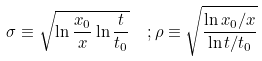<formula> <loc_0><loc_0><loc_500><loc_500>\sigma \equiv \sqrt { \ln \frac { x _ { 0 } } { x } \ln \frac { t } { t _ { 0 } } } \ \ ; \rho \equiv \sqrt { \frac { \ln x _ { 0 } / x } { \ln t / t _ { 0 } } }</formula> 